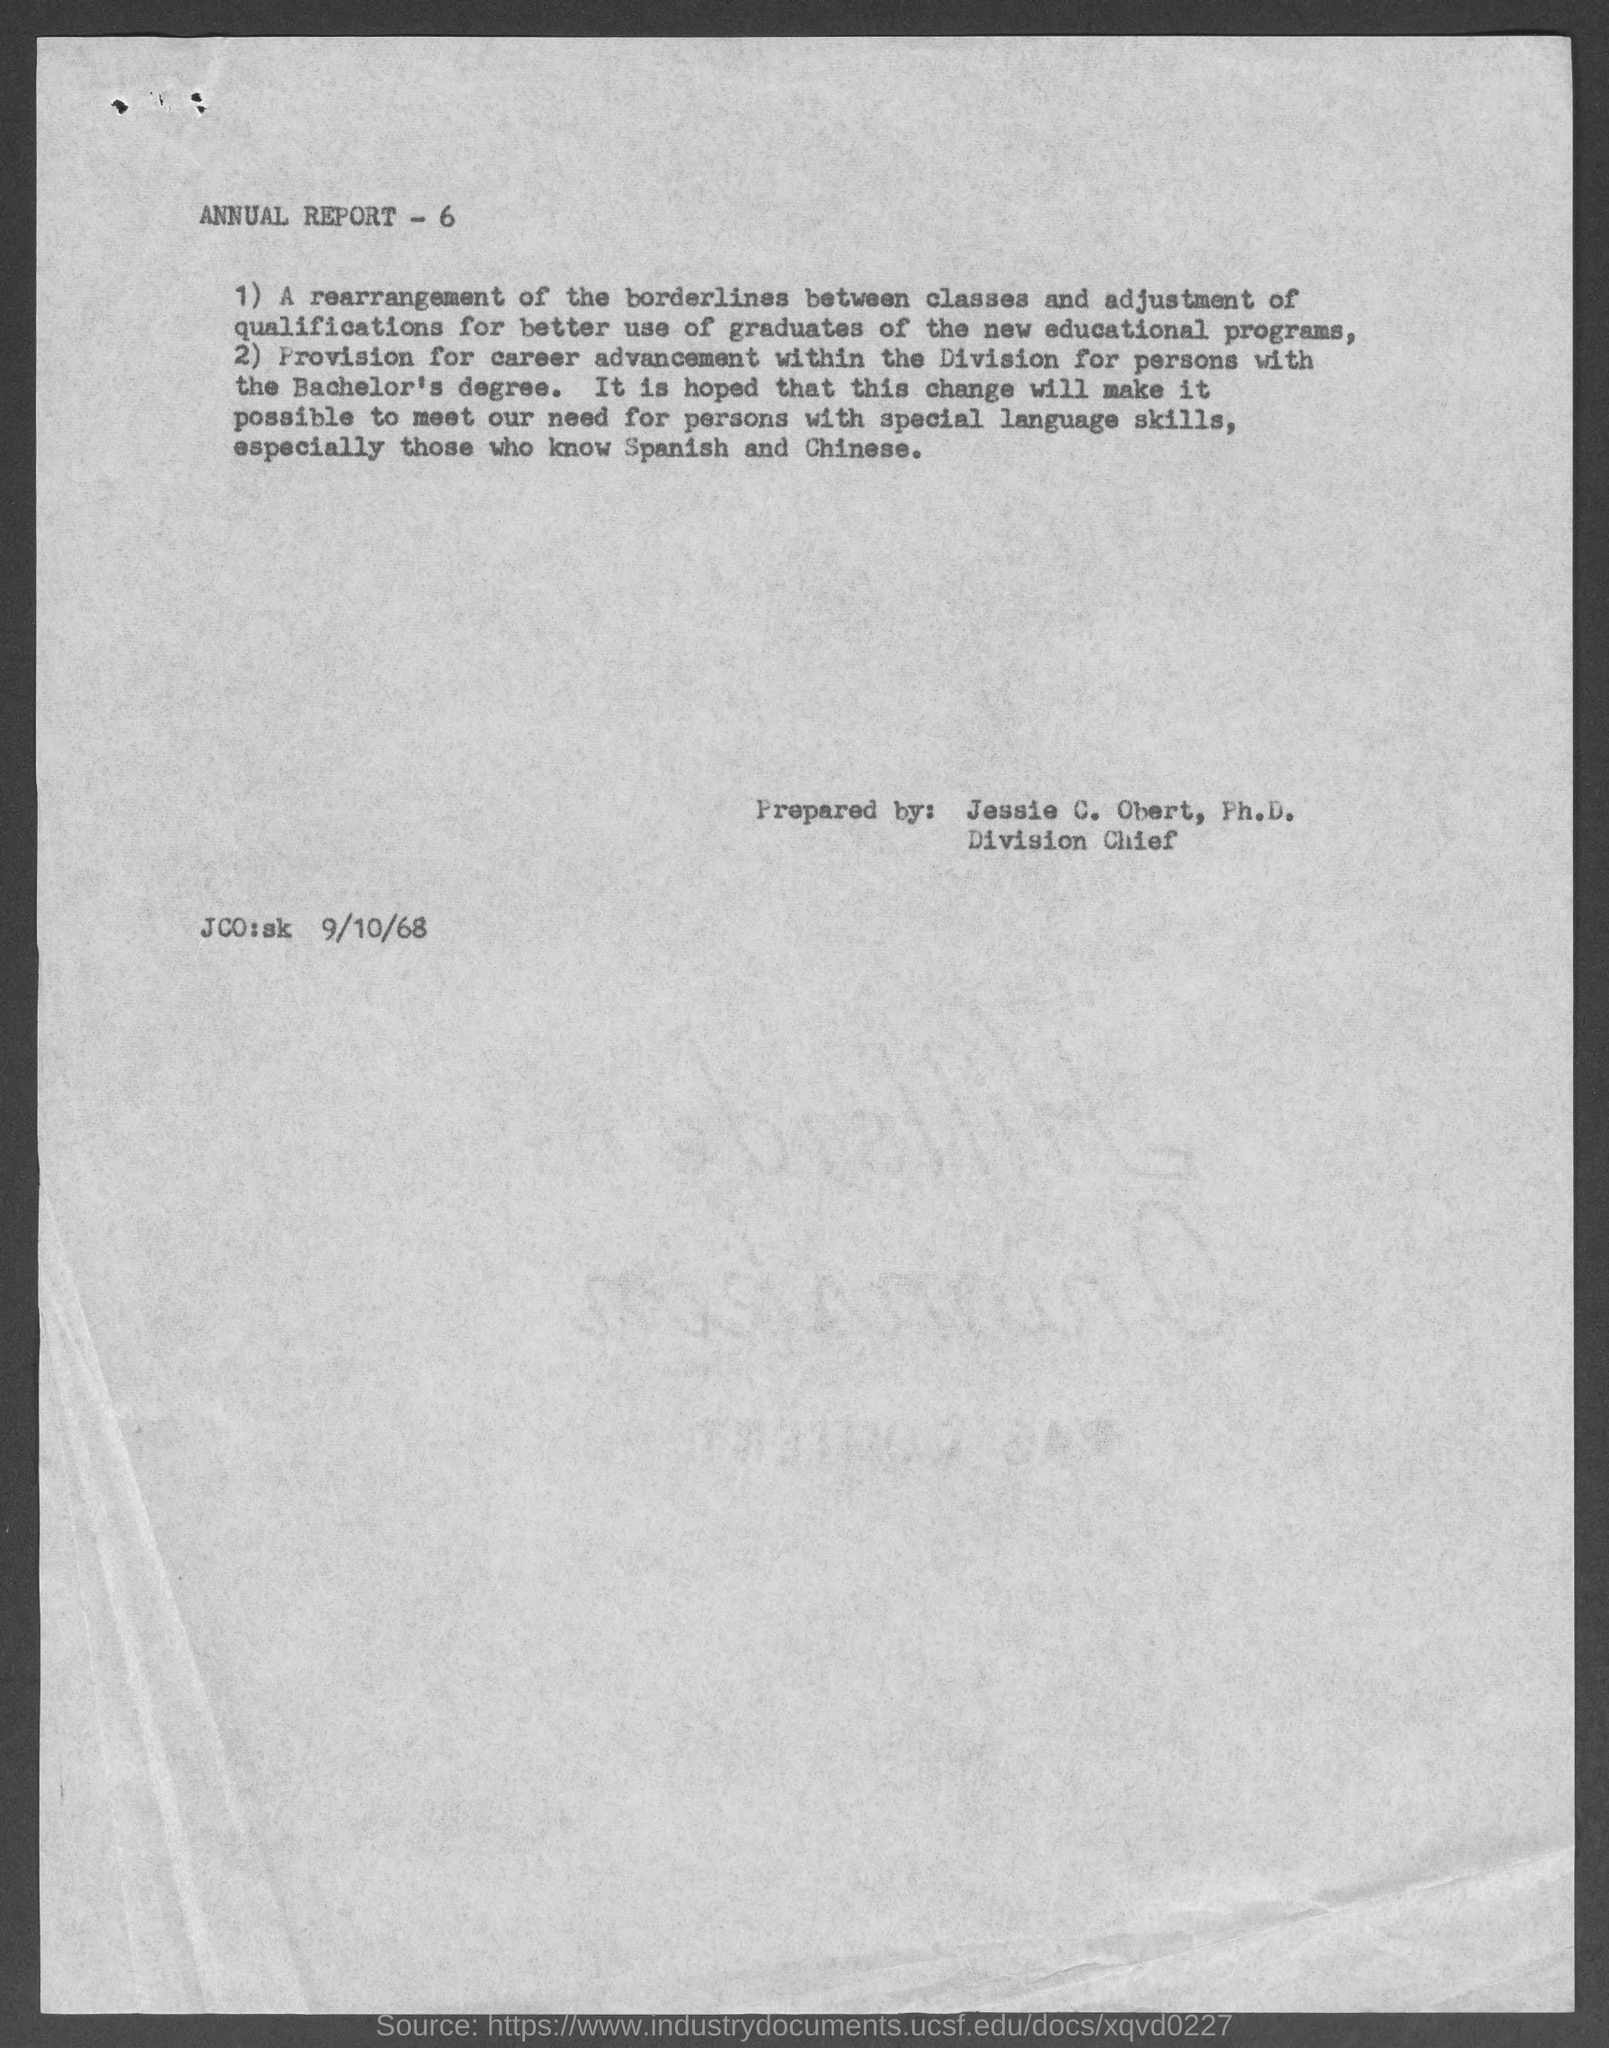What is the position of jessie c. obert, ph.d. ?
Offer a very short reply. Division Chief. Who prepared annual report -6?
Keep it short and to the point. Jessie C. Obert, Ph.D. 